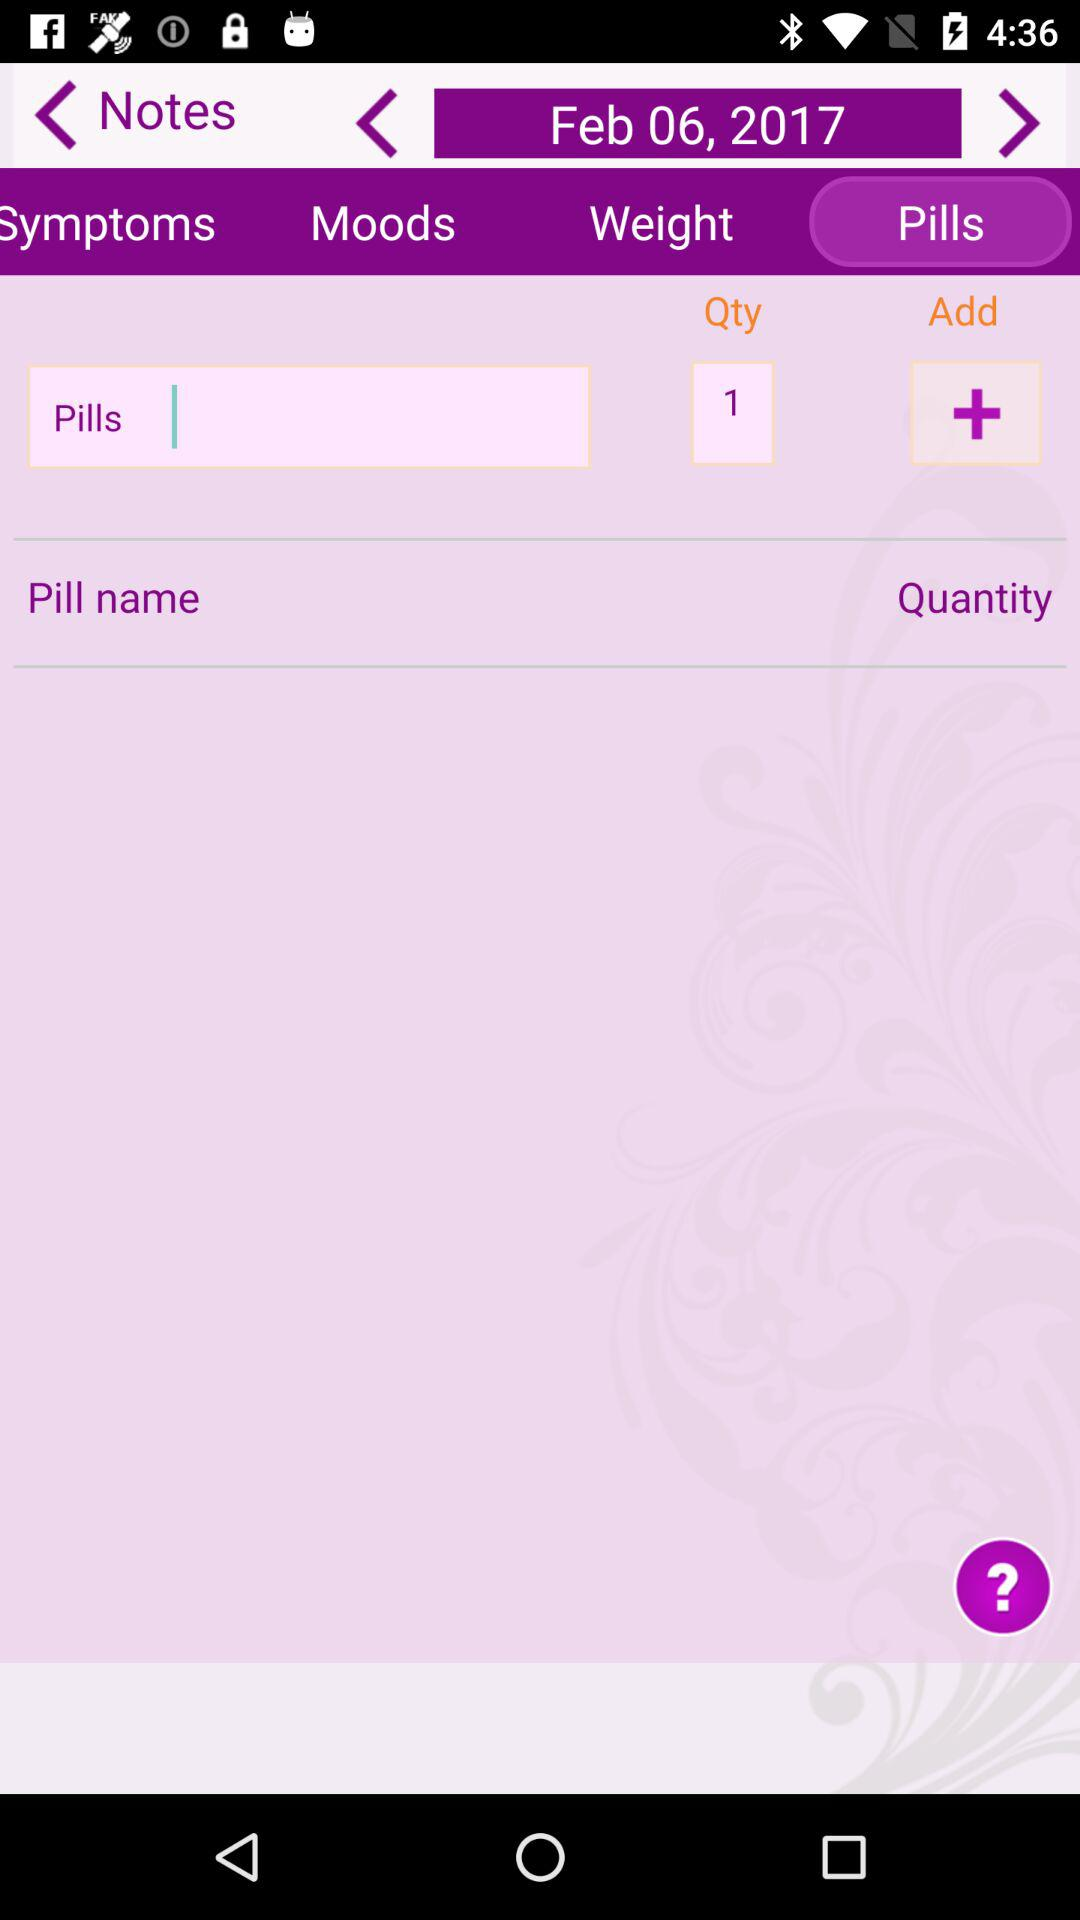What is the quantity of pills? The quantity of pills is 1. 